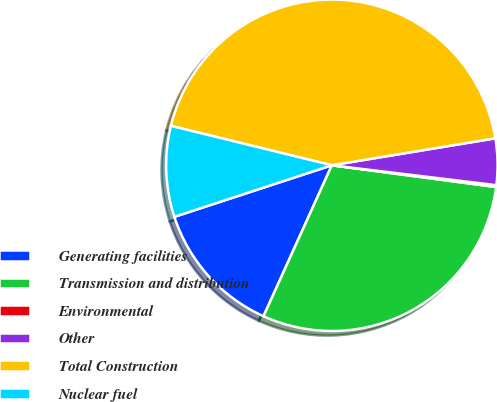Convert chart. <chart><loc_0><loc_0><loc_500><loc_500><pie_chart><fcel>Generating facilities<fcel>Transmission and distribution<fcel>Environmental<fcel>Other<fcel>Total Construction<fcel>Nuclear fuel<nl><fcel>13.2%<fcel>29.67%<fcel>0.18%<fcel>4.52%<fcel>43.58%<fcel>8.86%<nl></chart> 